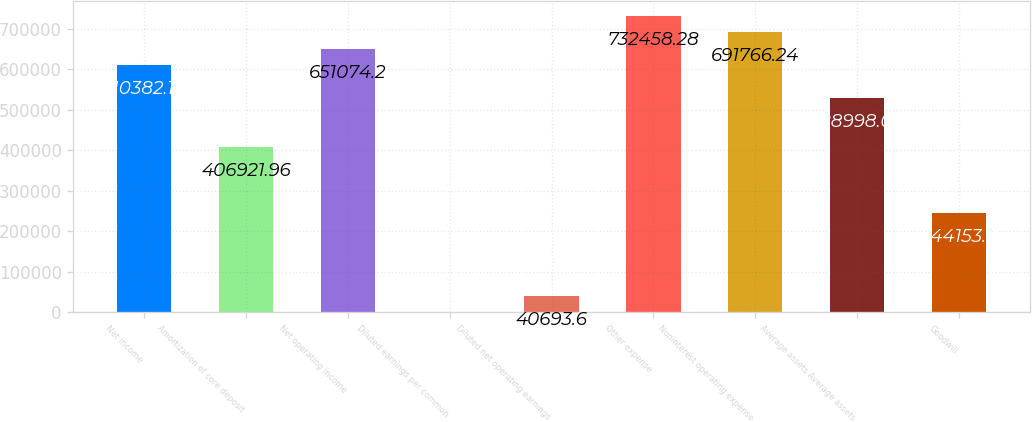Convert chart. <chart><loc_0><loc_0><loc_500><loc_500><bar_chart><fcel>Net income<fcel>Amortization of core deposit<fcel>Net operating income<fcel>Diluted earnings per common<fcel>Diluted net operating earnings<fcel>Other expense<fcel>Noninterest operating expense<fcel>Average assets Average assets<fcel>Goodwill<nl><fcel>610382<fcel>406922<fcel>651074<fcel>1.56<fcel>40693.6<fcel>732458<fcel>691766<fcel>528998<fcel>244154<nl></chart> 